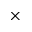Convert formula to latex. <formula><loc_0><loc_0><loc_500><loc_500>\times</formula> 